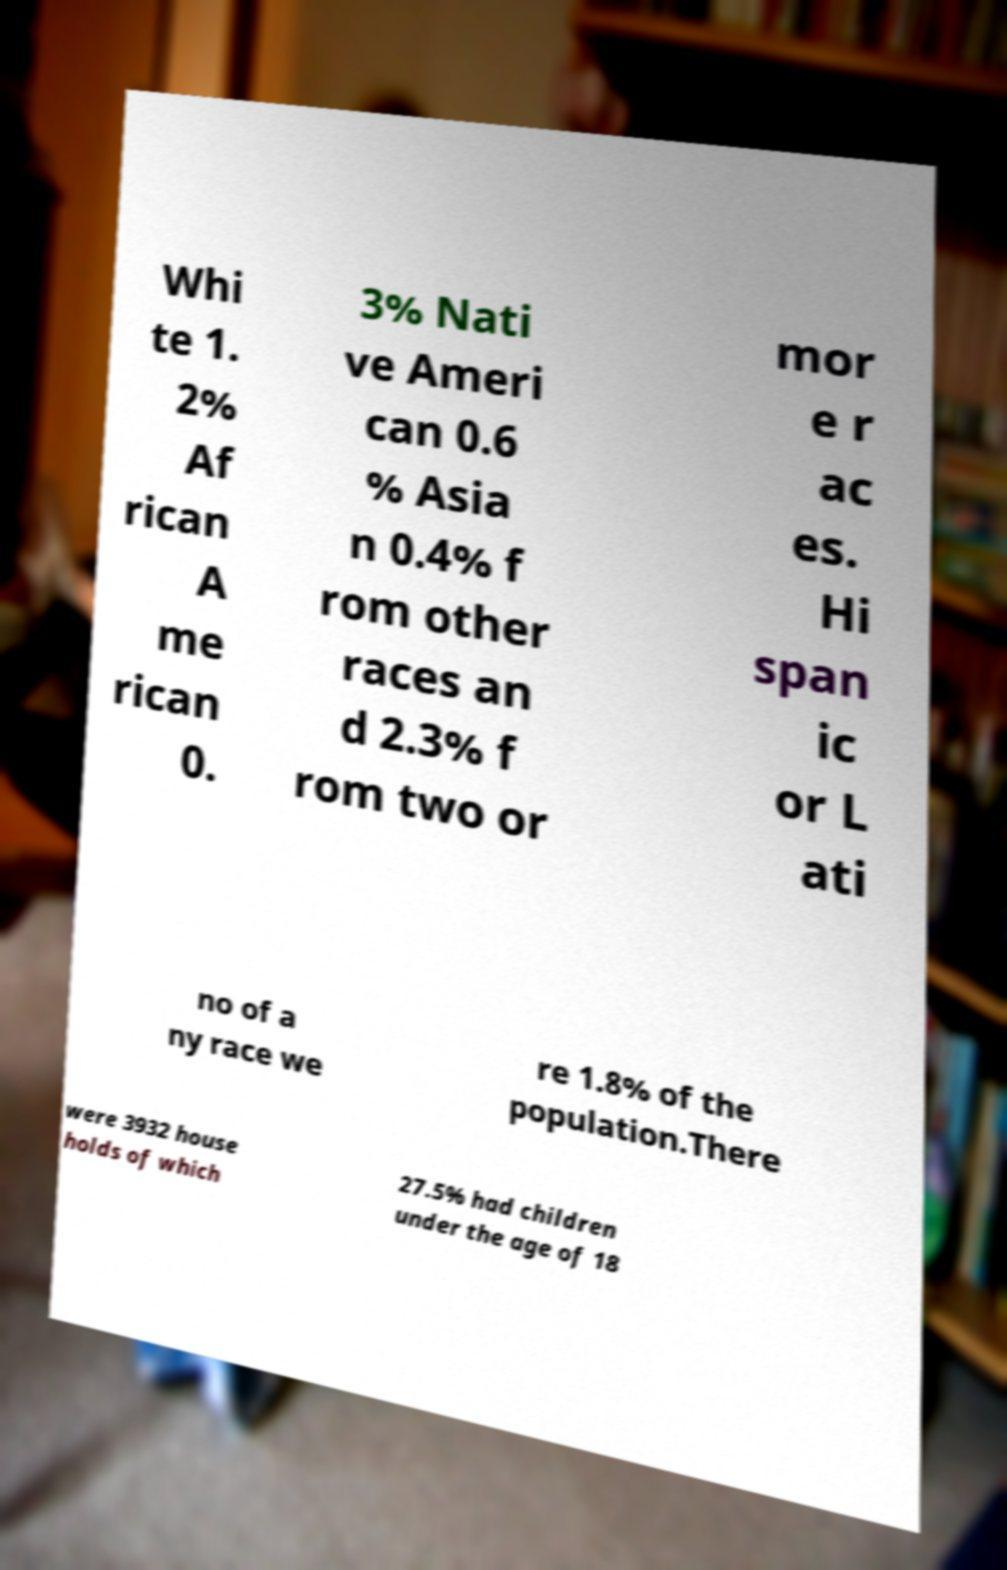Can you read and provide the text displayed in the image?This photo seems to have some interesting text. Can you extract and type it out for me? Whi te 1. 2% Af rican A me rican 0. 3% Nati ve Ameri can 0.6 % Asia n 0.4% f rom other races an d 2.3% f rom two or mor e r ac es. Hi span ic or L ati no of a ny race we re 1.8% of the population.There were 3932 house holds of which 27.5% had children under the age of 18 